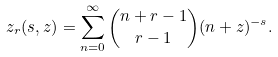<formula> <loc_0><loc_0><loc_500><loc_500>\ z _ { r } ( s , z ) = \sum ^ { \infty } _ { n = 0 } \binom { n + r - 1 } { r - 1 } ( n + z ) ^ { - s } .</formula> 